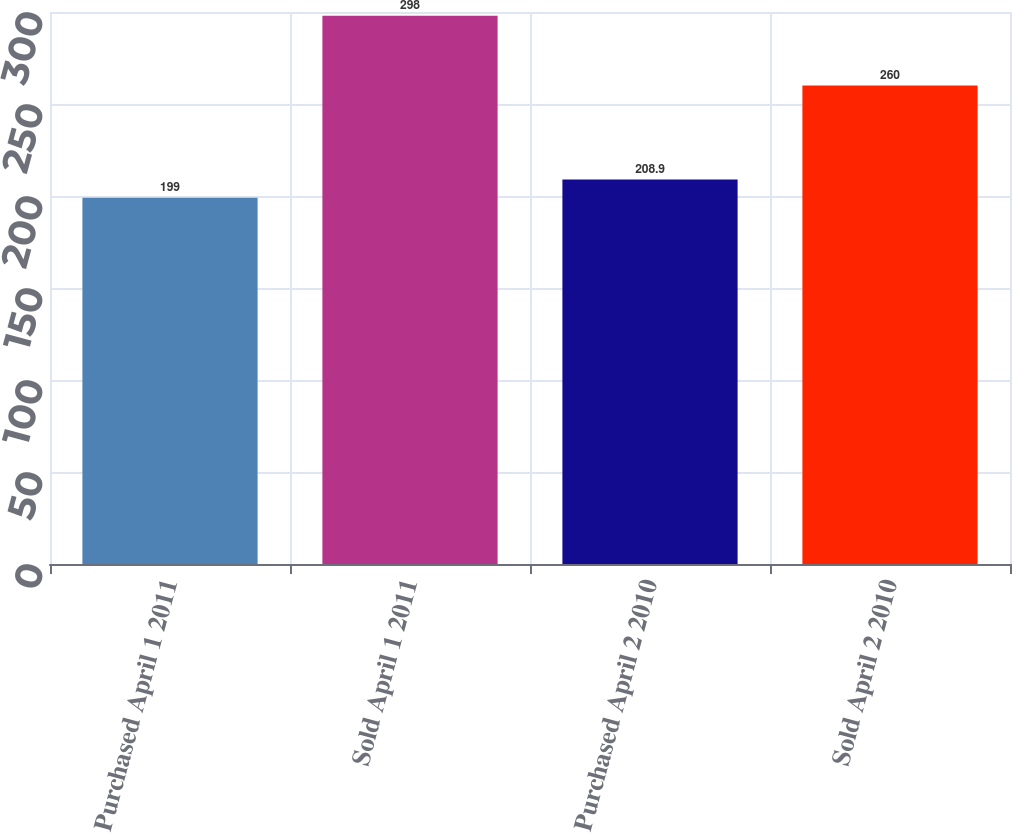Convert chart to OTSL. <chart><loc_0><loc_0><loc_500><loc_500><bar_chart><fcel>Purchased April 1 2011<fcel>Sold April 1 2011<fcel>Purchased April 2 2010<fcel>Sold April 2 2010<nl><fcel>199<fcel>298<fcel>208.9<fcel>260<nl></chart> 